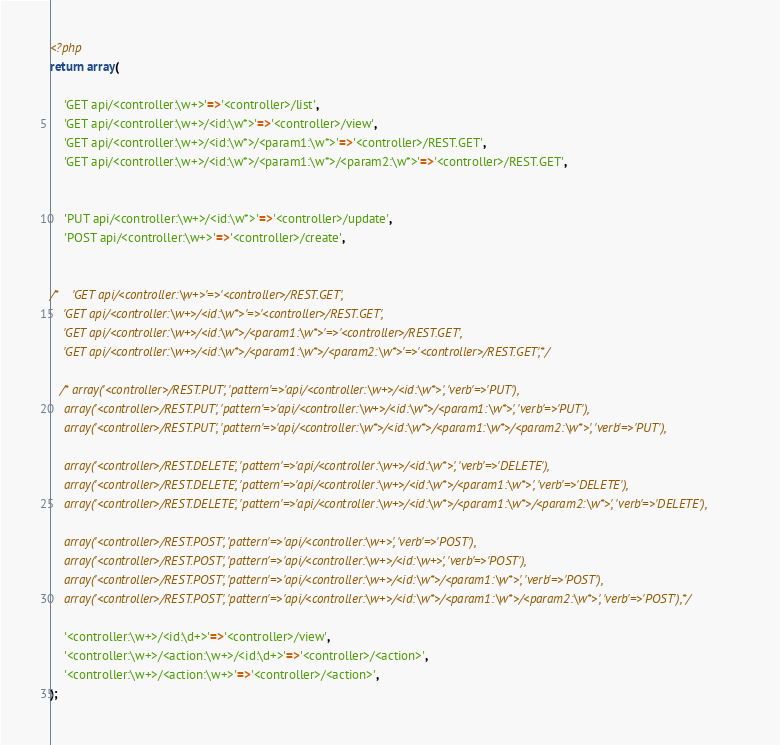Convert code to text. <code><loc_0><loc_0><loc_500><loc_500><_PHP_><?php
return array(

    'GET api/<controller:\w+>'=>'<controller>/list',
    'GET api/<controller:\w+>/<id:\w*>'=>'<controller>/view',
    'GET api/<controller:\w+>/<id:\w*>/<param1:\w*>'=>'<controller>/REST.GET',
    'GET api/<controller:\w+>/<id:\w*>/<param1:\w*>/<param2:\w*>'=>'<controller>/REST.GET',


    'PUT api/<controller:\w+>/<id:\w*>'=>'<controller>/update',
    'POST api/<controller:\w+>'=>'<controller>/create',


/*    'GET api/<controller:\w+>'=>'<controller>/REST.GET',
    'GET api/<controller:\w+>/<id:\w*>'=>'<controller>/REST.GET',
    'GET api/<controller:\w+>/<id:\w*>/<param1:\w*>'=>'<controller>/REST.GET',
    'GET api/<controller:\w+>/<id:\w*>/<param1:\w*>/<param2:\w*>'=>'<controller>/REST.GET',*/

   /* array('<controller>/REST.PUT', 'pattern'=>'api/<controller:\w+>/<id:\w*>', 'verb'=>'PUT'),
    array('<controller>/REST.PUT', 'pattern'=>'api/<controller:\w+>/<id:\w*>/<param1:\w*>', 'verb'=>'PUT'),
    array('<controller>/REST.PUT', 'pattern'=>'api/<controller:\w*>/<id:\w*>/<param1:\w*>/<param2:\w*>', 'verb'=>'PUT'),

    array('<controller>/REST.DELETE', 'pattern'=>'api/<controller:\w+>/<id:\w*>', 'verb'=>'DELETE'),
    array('<controller>/REST.DELETE', 'pattern'=>'api/<controller:\w+>/<id:\w*>/<param1:\w*>', 'verb'=>'DELETE'),
    array('<controller>/REST.DELETE', 'pattern'=>'api/<controller:\w+>/<id:\w*>/<param1:\w*>/<param2:\w*>', 'verb'=>'DELETE'),

    array('<controller>/REST.POST', 'pattern'=>'api/<controller:\w+>', 'verb'=>'POST'),
    array('<controller>/REST.POST', 'pattern'=>'api/<controller:\w+>/<id:\w+>', 'verb'=>'POST'),
    array('<controller>/REST.POST', 'pattern'=>'api/<controller:\w+>/<id:\w*>/<param1:\w*>', 'verb'=>'POST'),
    array('<controller>/REST.POST', 'pattern'=>'api/<controller:\w+>/<id:\w*>/<param1:\w*>/<param2:\w*>', 'verb'=>'POST'),*/

    '<controller:\w+>/<id:\d+>'=>'<controller>/view',
    '<controller:\w+>/<action:\w+>/<id:\d+>'=>'<controller>/<action>',
    '<controller:\w+>/<action:\w+>'=>'<controller>/<action>',
);</code> 